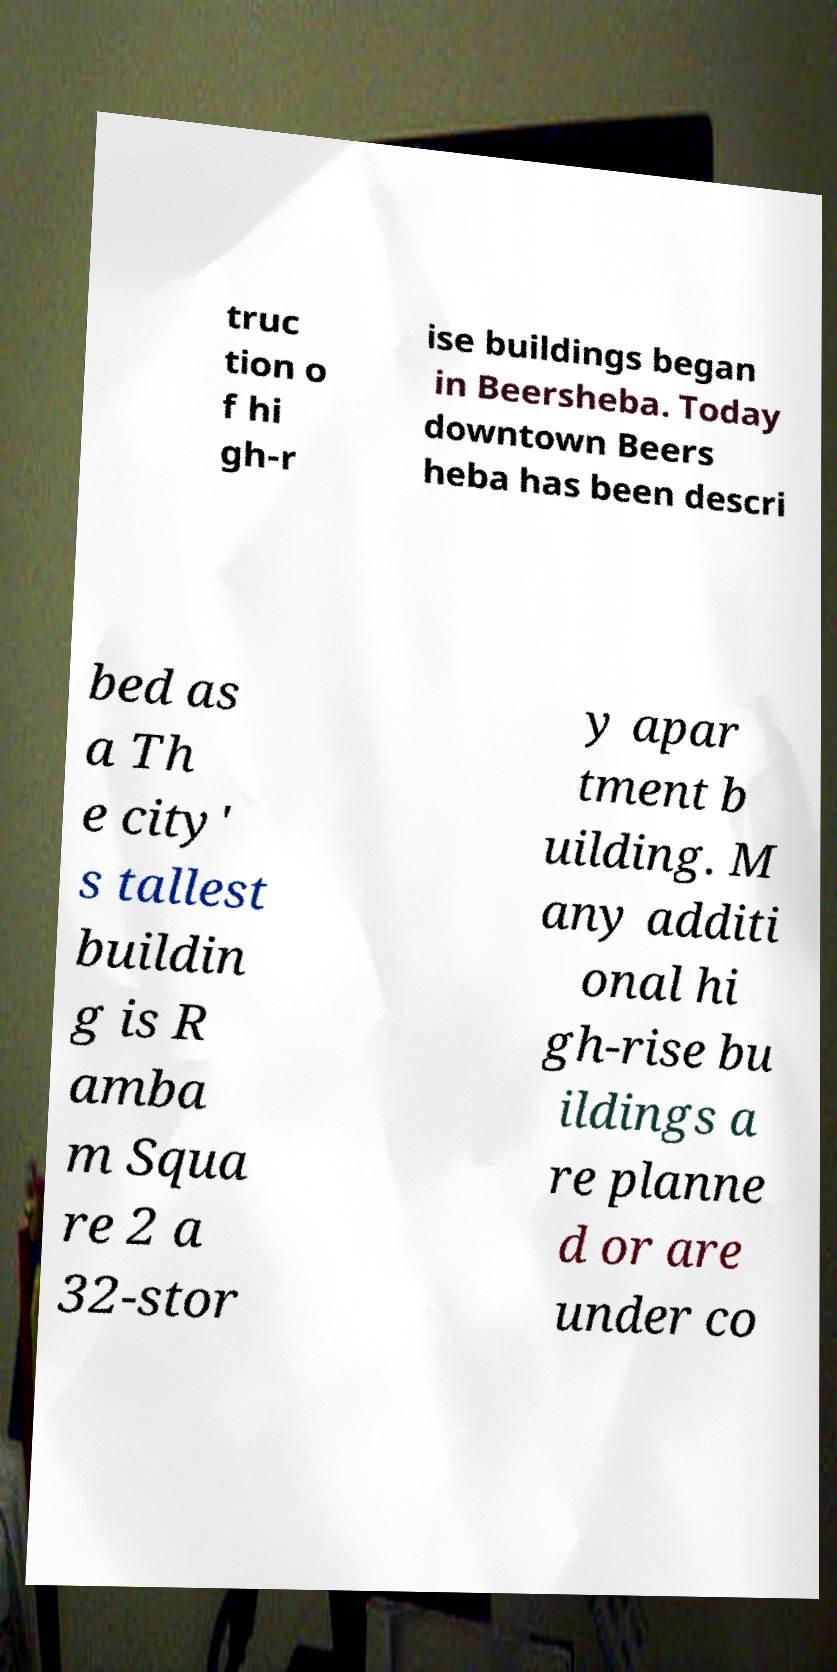Could you extract and type out the text from this image? truc tion o f hi gh-r ise buildings began in Beersheba. Today downtown Beers heba has been descri bed as a Th e city' s tallest buildin g is R amba m Squa re 2 a 32-stor y apar tment b uilding. M any additi onal hi gh-rise bu ildings a re planne d or are under co 